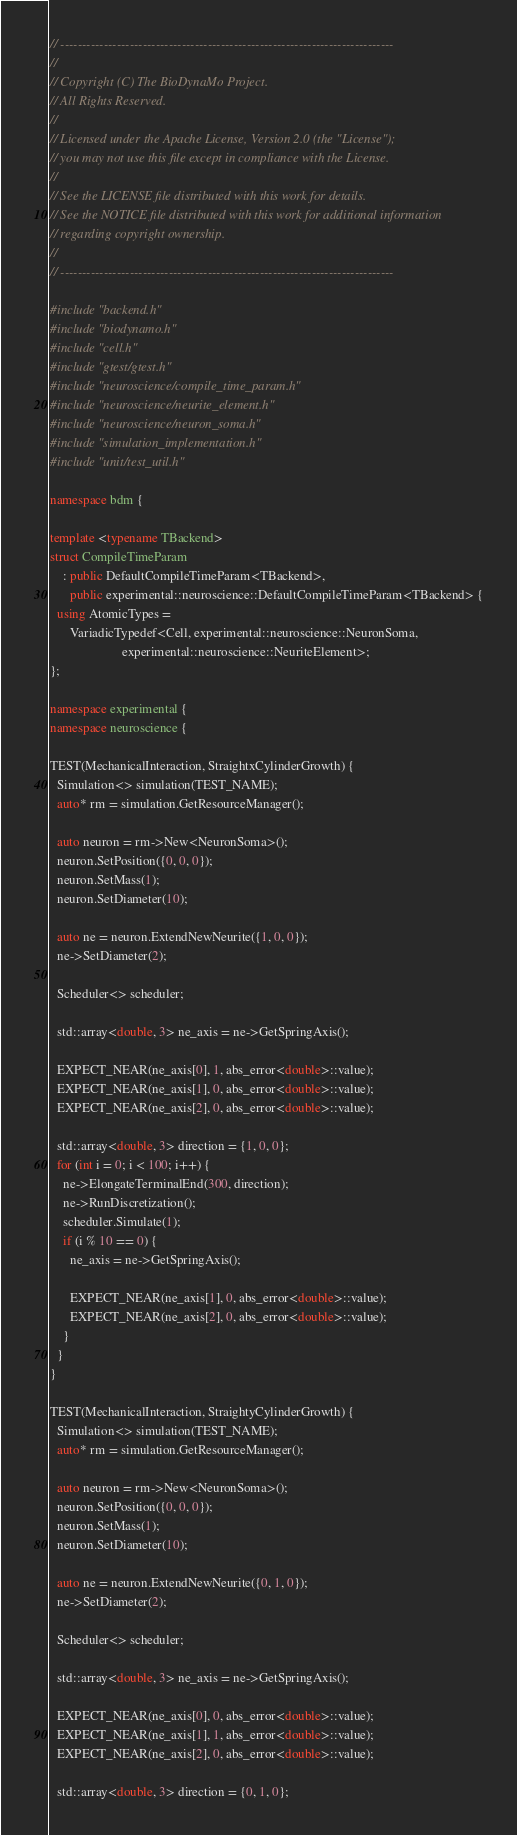Convert code to text. <code><loc_0><loc_0><loc_500><loc_500><_C++_>// -----------------------------------------------------------------------------
//
// Copyright (C) The BioDynaMo Project.
// All Rights Reserved.
//
// Licensed under the Apache License, Version 2.0 (the "License");
// you may not use this file except in compliance with the License.
//
// See the LICENSE file distributed with this work for details.
// See the NOTICE file distributed with this work for additional information
// regarding copyright ownership.
//
// -----------------------------------------------------------------------------

#include "backend.h"
#include "biodynamo.h"
#include "cell.h"
#include "gtest/gtest.h"
#include "neuroscience/compile_time_param.h"
#include "neuroscience/neurite_element.h"
#include "neuroscience/neuron_soma.h"
#include "simulation_implementation.h"
#include "unit/test_util.h"

namespace bdm {

template <typename TBackend>
struct CompileTimeParam
    : public DefaultCompileTimeParam<TBackend>,
      public experimental::neuroscience::DefaultCompileTimeParam<TBackend> {
  using AtomicTypes =
      VariadicTypedef<Cell, experimental::neuroscience::NeuronSoma,
                      experimental::neuroscience::NeuriteElement>;
};

namespace experimental {
namespace neuroscience {

TEST(MechanicalInteraction, StraightxCylinderGrowth) {
  Simulation<> simulation(TEST_NAME);
  auto* rm = simulation.GetResourceManager();

  auto neuron = rm->New<NeuronSoma>();
  neuron.SetPosition({0, 0, 0});
  neuron.SetMass(1);
  neuron.SetDiameter(10);

  auto ne = neuron.ExtendNewNeurite({1, 0, 0});
  ne->SetDiameter(2);

  Scheduler<> scheduler;

  std::array<double, 3> ne_axis = ne->GetSpringAxis();

  EXPECT_NEAR(ne_axis[0], 1, abs_error<double>::value);
  EXPECT_NEAR(ne_axis[1], 0, abs_error<double>::value);
  EXPECT_NEAR(ne_axis[2], 0, abs_error<double>::value);

  std::array<double, 3> direction = {1, 0, 0};
  for (int i = 0; i < 100; i++) {
    ne->ElongateTerminalEnd(300, direction);
    ne->RunDiscretization();
    scheduler.Simulate(1);
    if (i % 10 == 0) {
      ne_axis = ne->GetSpringAxis();

      EXPECT_NEAR(ne_axis[1], 0, abs_error<double>::value);
      EXPECT_NEAR(ne_axis[2], 0, abs_error<double>::value);
    }
  }
}

TEST(MechanicalInteraction, StraightyCylinderGrowth) {
  Simulation<> simulation(TEST_NAME);
  auto* rm = simulation.GetResourceManager();

  auto neuron = rm->New<NeuronSoma>();
  neuron.SetPosition({0, 0, 0});
  neuron.SetMass(1);
  neuron.SetDiameter(10);

  auto ne = neuron.ExtendNewNeurite({0, 1, 0});
  ne->SetDiameter(2);

  Scheduler<> scheduler;

  std::array<double, 3> ne_axis = ne->GetSpringAxis();

  EXPECT_NEAR(ne_axis[0], 0, abs_error<double>::value);
  EXPECT_NEAR(ne_axis[1], 1, abs_error<double>::value);
  EXPECT_NEAR(ne_axis[2], 0, abs_error<double>::value);

  std::array<double, 3> direction = {0, 1, 0};</code> 